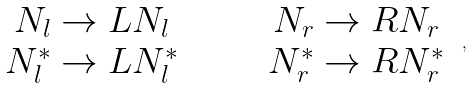<formula> <loc_0><loc_0><loc_500><loc_500>\begin{array} { c c } N _ { l } \rightarrow L N _ { l } \quad & \quad N _ { r } \rightarrow R N _ { r } \\ N _ { l } ^ { * } \rightarrow L N _ { l } ^ { * } \quad & \quad N _ { r } ^ { * } \rightarrow R N _ { r } ^ { * } \end{array} \ ,</formula> 